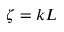Convert formula to latex. <formula><loc_0><loc_0><loc_500><loc_500>\zeta = k L</formula> 